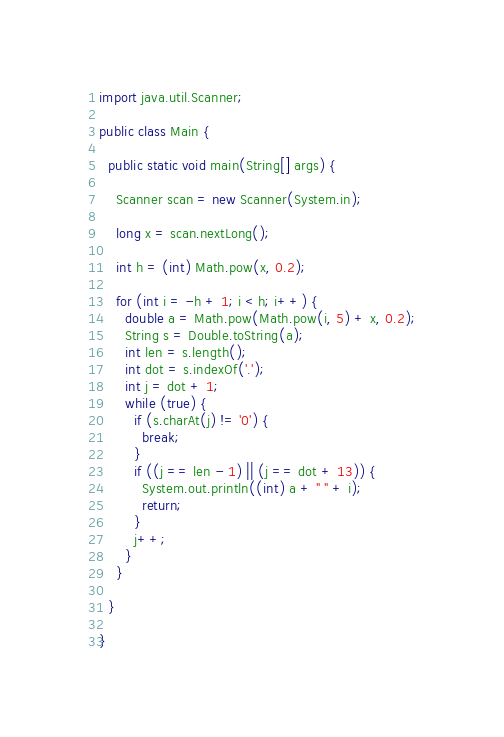Convert code to text. <code><loc_0><loc_0><loc_500><loc_500><_Java_>import java.util.Scanner;

public class Main {

  public static void main(String[] args) {

    Scanner scan = new Scanner(System.in);

    long x = scan.nextLong();

    int h = (int) Math.pow(x, 0.2);

    for (int i = -h + 1; i < h; i++) {
      double a = Math.pow(Math.pow(i, 5) + x, 0.2);
      String s = Double.toString(a);
      int len = s.length();
      int dot = s.indexOf('.');
      int j = dot + 1;
      while (true) {
        if (s.charAt(j) != '0') {
          break;
        }
        if ((j == len - 1) || (j == dot + 13)) {
          System.out.println((int) a + " " + i);
          return;
        }
        j++;
      }
    }

  }

}</code> 